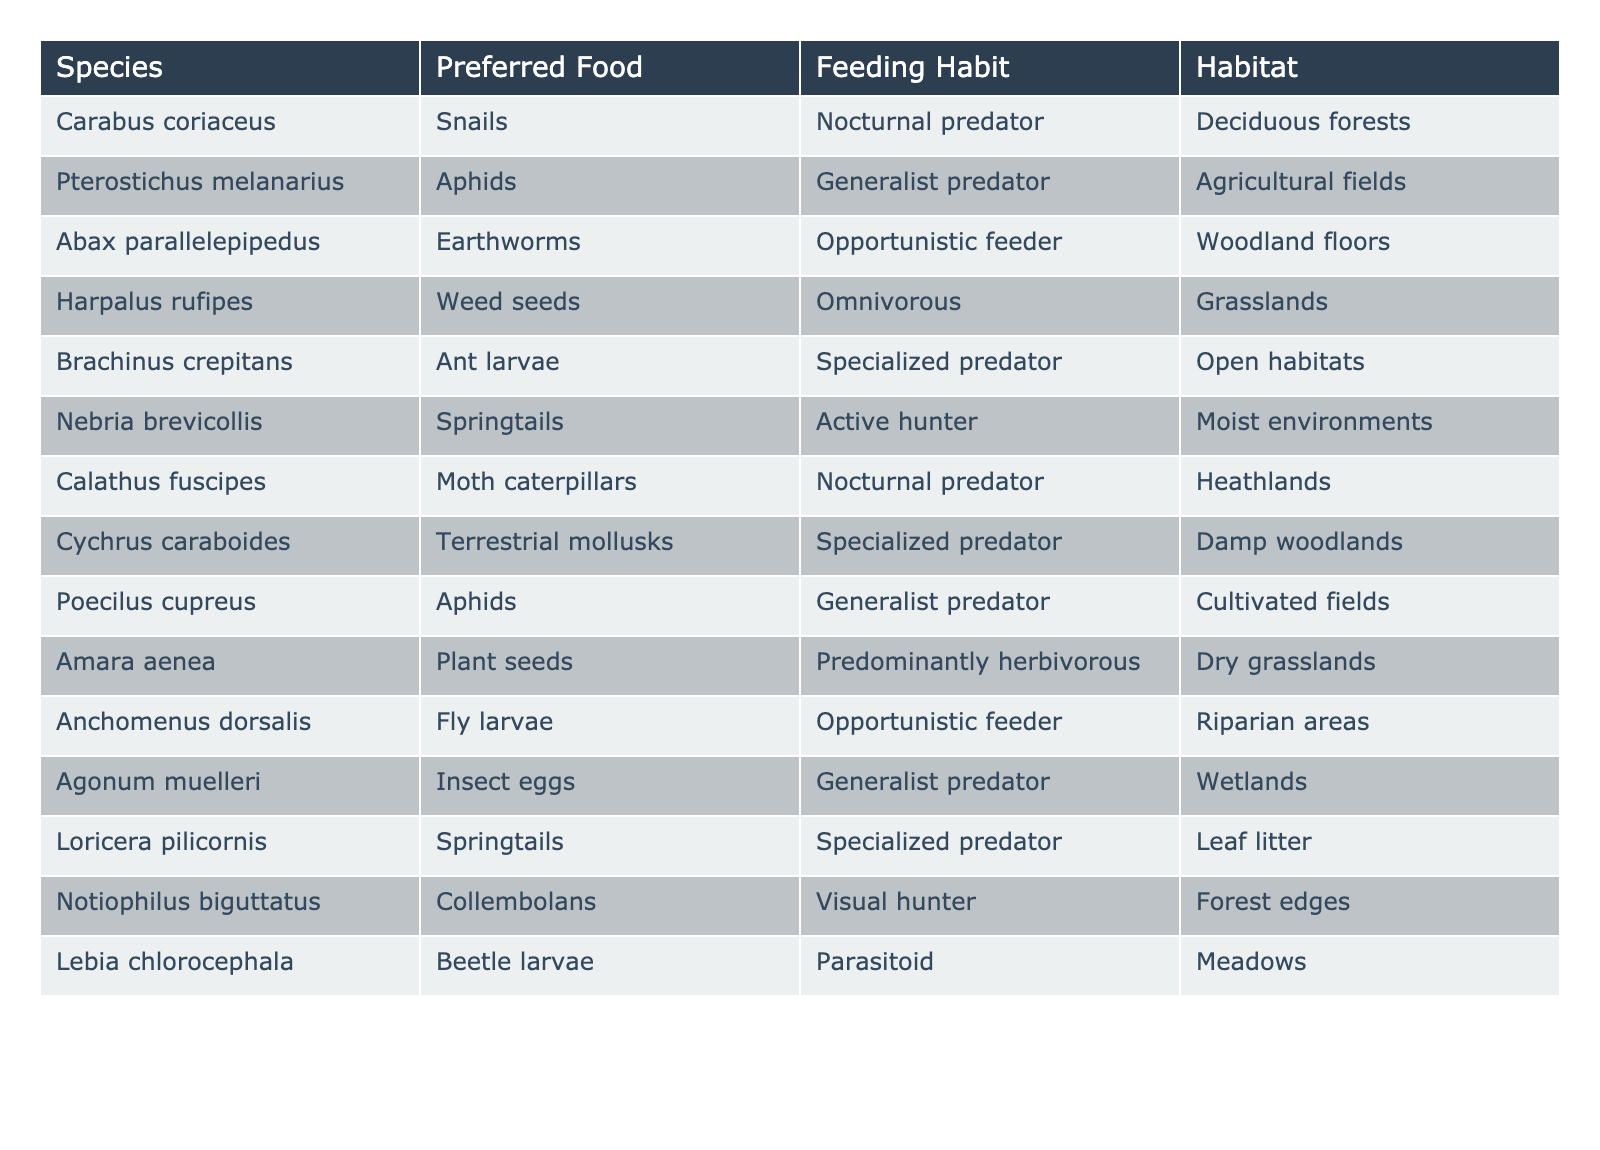What is the preferred food of Harpalus rufipes? From the table, we can directly look at the row for Harpalus rufipes and see that its preferred food is weed seeds.
Answer: Weed seeds Which species are specialized predators? By scanning the table, we can identify the species listed under the Feeding Habit column with the label "Specialized predator." They are Brachinus crepitans, Cychrus caraboides, and Loricera pilicornis.
Answer: Brachinus crepitans, Cychrus caraboides, Loricera pilicornis Is Amara aenea a nocturnal predator? In the table, Amara aenea's Feeding Habit is listed as predominantly herbivorous, which does not indicate that it is a nocturnal predator. Therefore, the answer is no.
Answer: No How many species feed on insect eggs or larvae? By reviewing the table, we note that Agonum muelleri feeds on insect eggs, and Lebia chlorocephala feeds on beetle larvae. Adding these gives us a total of 2 species.
Answer: 2 What habitats do generalist predators inhabit? Referring to the table, generalist predators listed are Pterostichus melanarius, Poecilus cupreus, and Agonum muelleri. Their respective habitats are agricultural fields, cultivated fields, and wetlands. Thus, generalist predators inhabit these types of habitats.
Answer: Agricultural fields, cultivated fields, wetlands Which species prefers food sources found in moist environments? The table lists Nebria brevicollis as an active hunter that prefers springtails, a food source found in moist environments.
Answer: Nebria brevicollis Are there any species that have the same preferred food? Scanning the table, we notice that Pterostichus melanarius and Poecilus cupreus both prefer aphids as their food source. Hence, there are species that share the same preferred food.
Answer: Yes What is the average number of food categories (unique preferred foods) across all species? Counting each unique Preferred Food in the table gives us 12 distinct food categories. Considering we have 12 species, we find the average is 12/12 = 1.
Answer: 1 How many species are nocturnal predators? By examining the table, we can find that there are three species listed as nocturnal predators: Carabus coriaceus, Calathus fuscipes, and Amara aenea.
Answer: 3 Do all species in deciduous forests strictly eat only one food type? Checking the habitat of Carabus coriaceus, it is the only species listed from deciduous forests and it exclusively eats snails, indicating that yes, this species has a strict diet.
Answer: Yes 